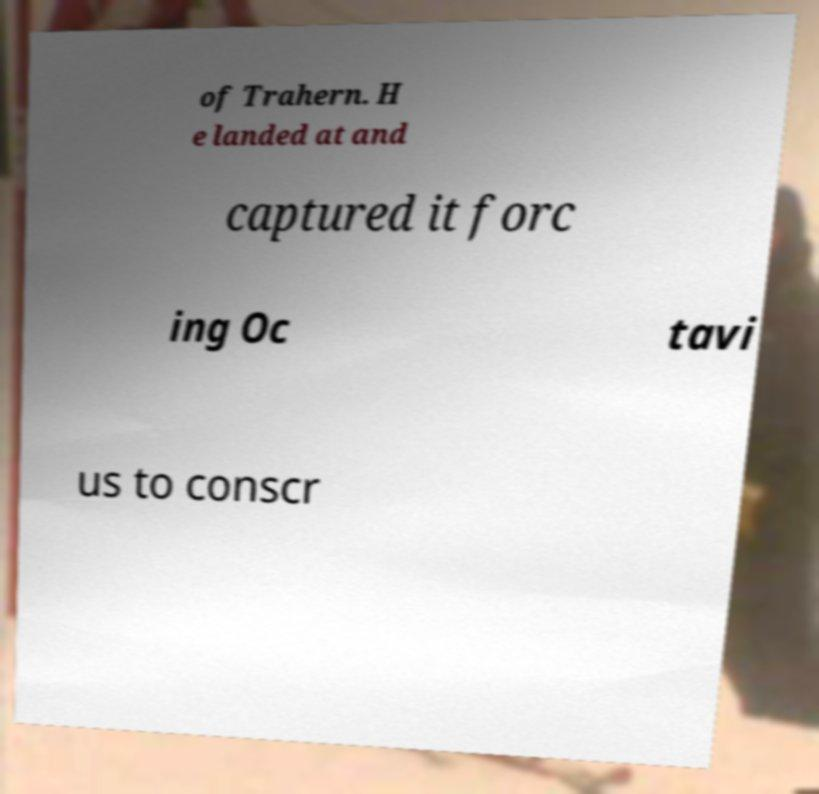I need the written content from this picture converted into text. Can you do that? of Trahern. H e landed at and captured it forc ing Oc tavi us to conscr 